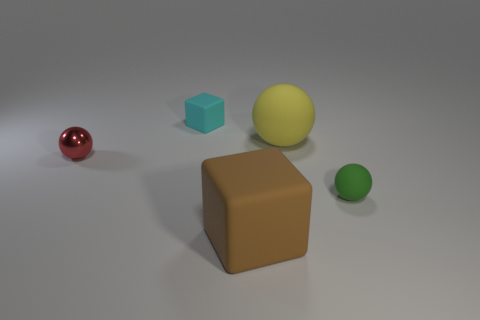Add 1 big purple shiny blocks. How many objects exist? 6 Subtract all balls. How many objects are left? 2 Add 4 brown blocks. How many brown blocks exist? 5 Subtract 0 green cylinders. How many objects are left? 5 Subtract all tiny green rubber spheres. Subtract all small rubber cubes. How many objects are left? 3 Add 1 metallic things. How many metallic things are left? 2 